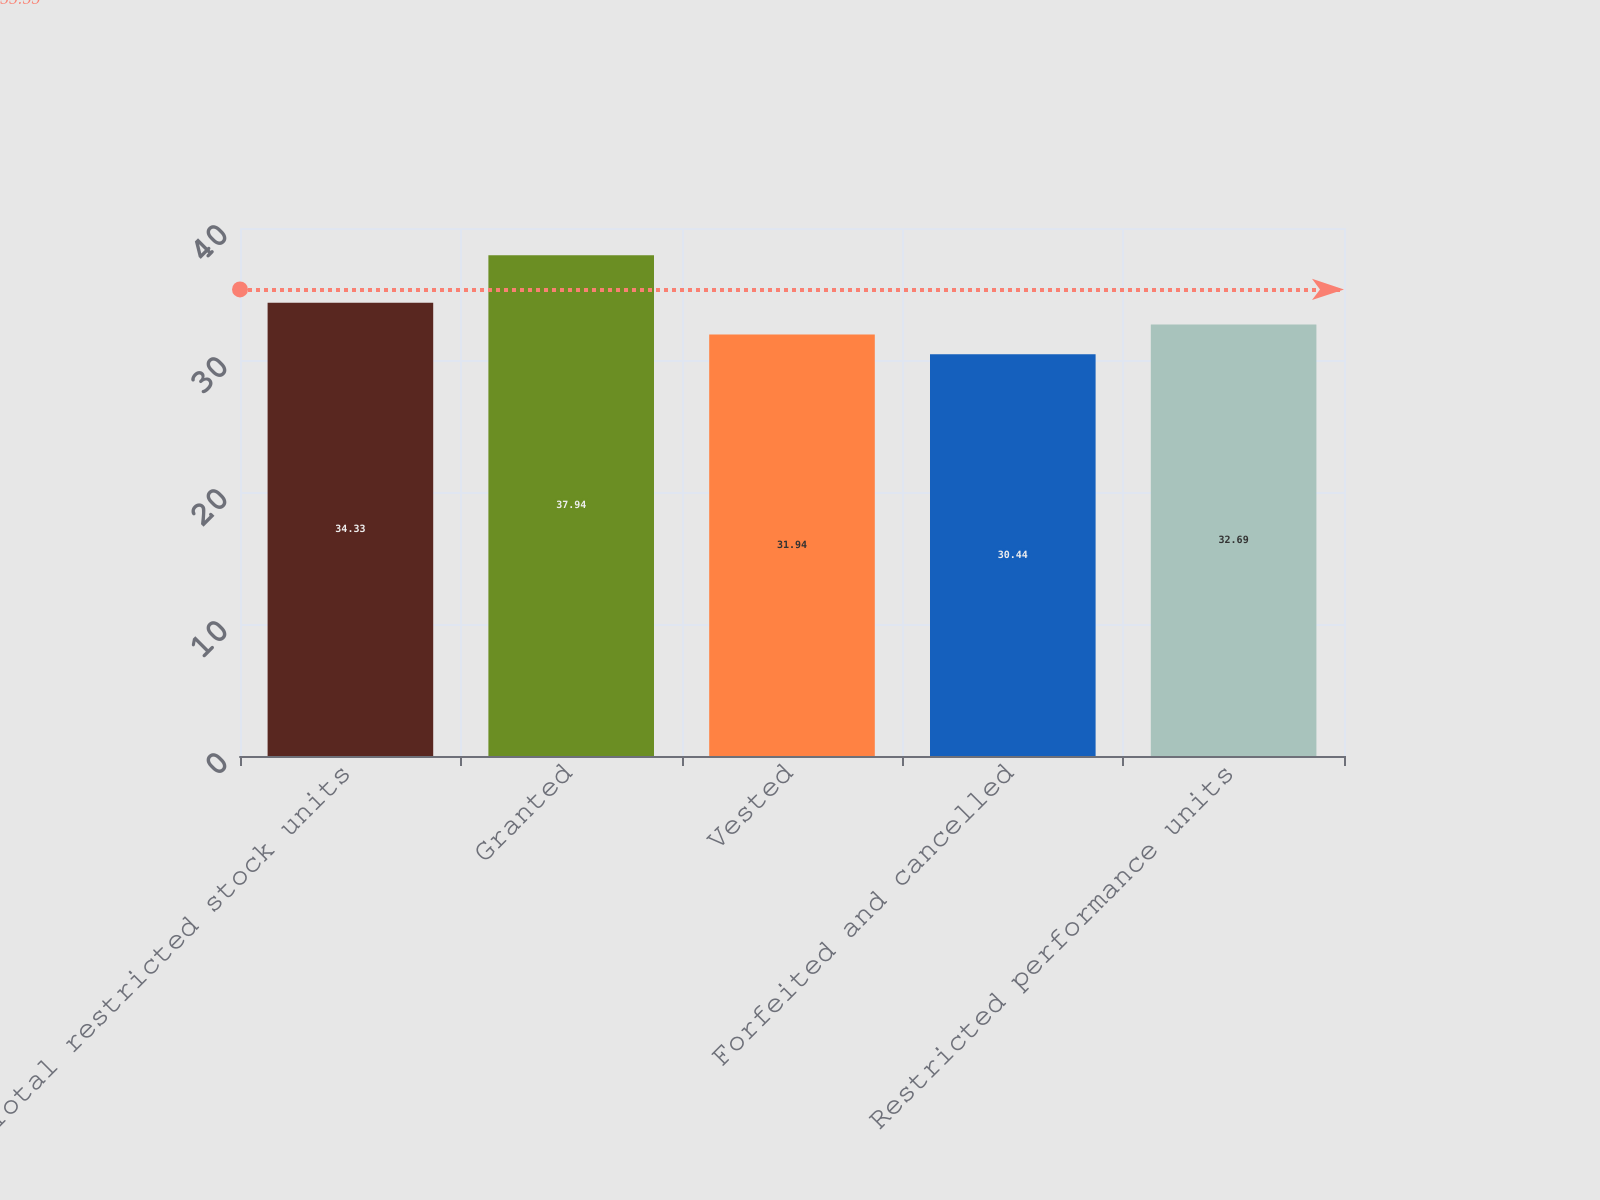Convert chart. <chart><loc_0><loc_0><loc_500><loc_500><bar_chart><fcel>Total restricted stock units<fcel>Granted<fcel>Vested<fcel>Forfeited and cancelled<fcel>Restricted performance units<nl><fcel>34.33<fcel>37.94<fcel>31.94<fcel>30.44<fcel>32.69<nl></chart> 